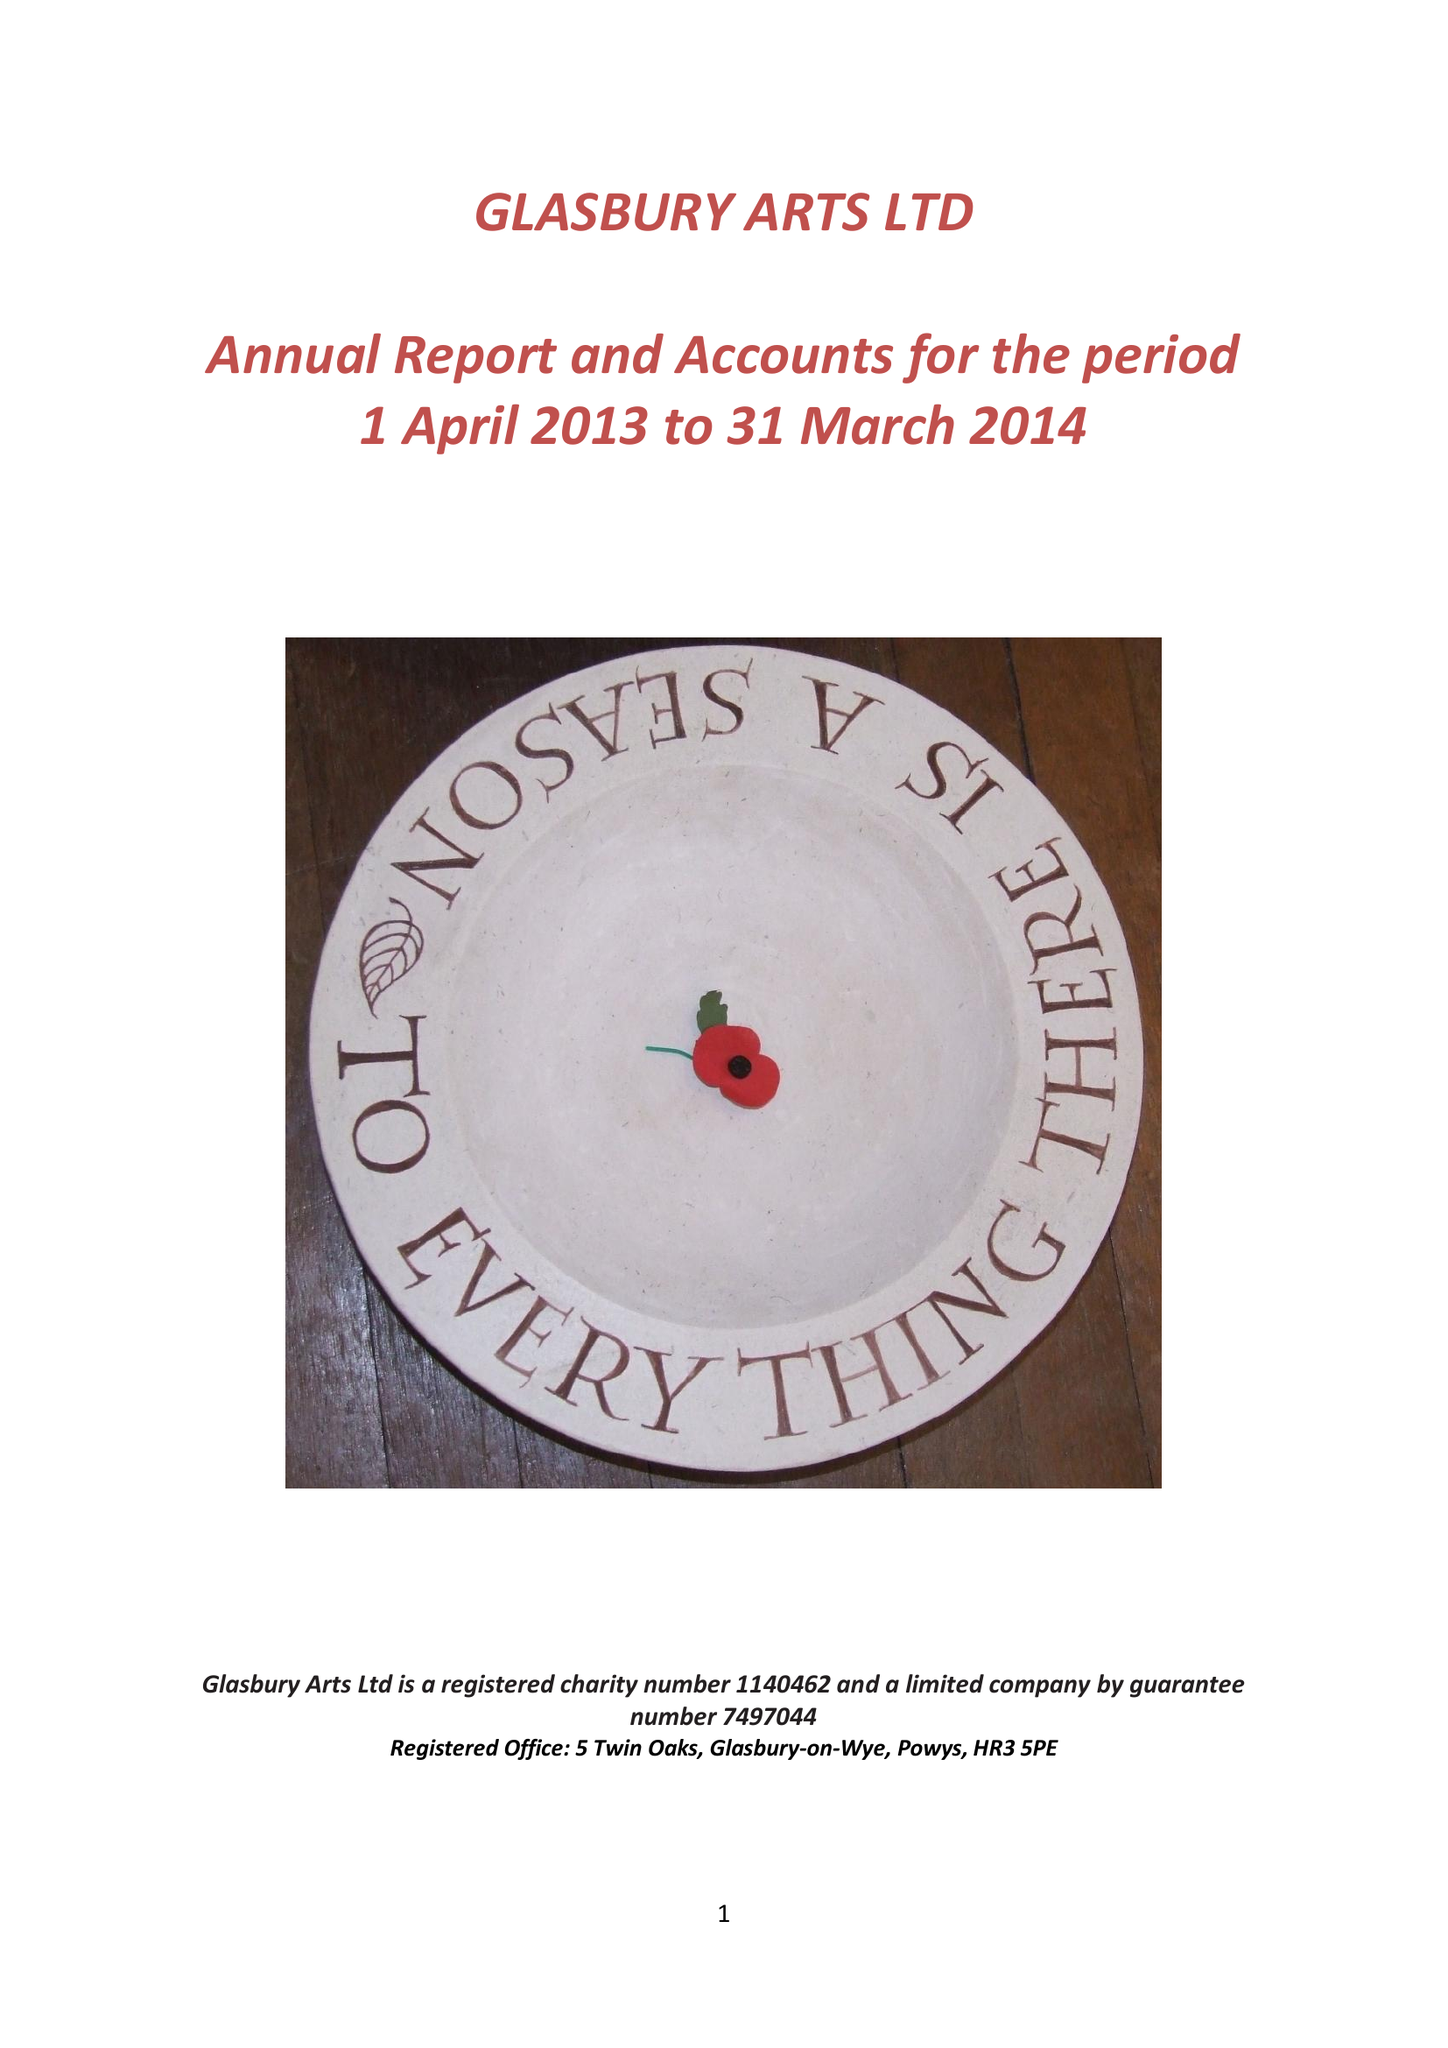What is the value for the charity_name?
Answer the question using a single word or phrase. Glasbury Arts Ltd. 